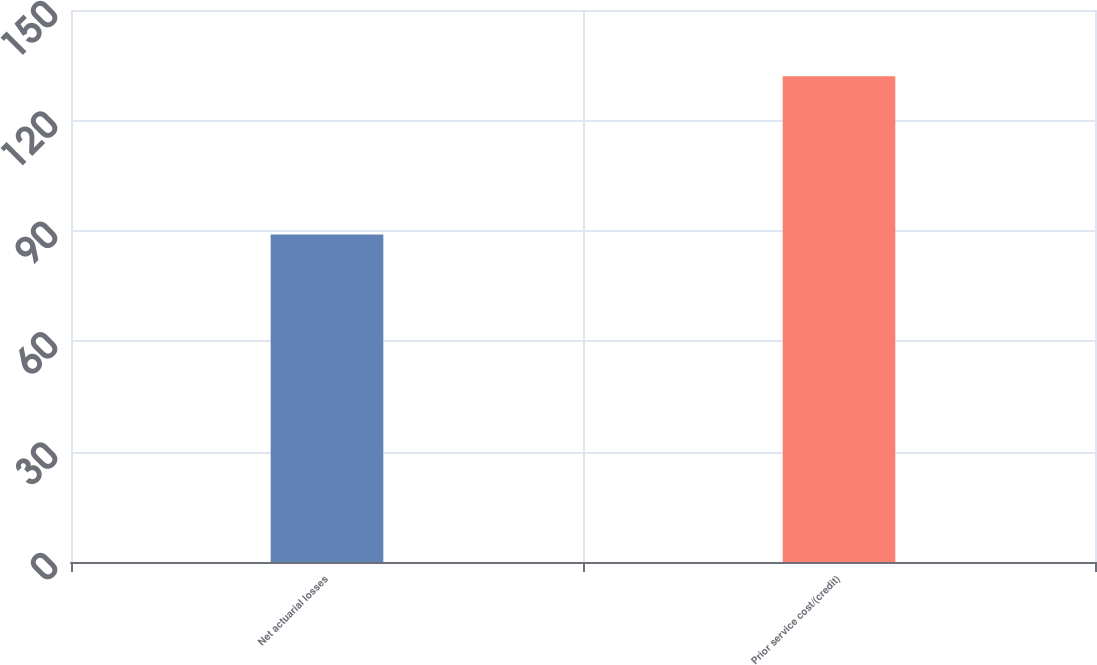Convert chart to OTSL. <chart><loc_0><loc_0><loc_500><loc_500><bar_chart><fcel>Net actuarial losses<fcel>Prior service cost/(credit)<nl><fcel>89<fcel>132<nl></chart> 